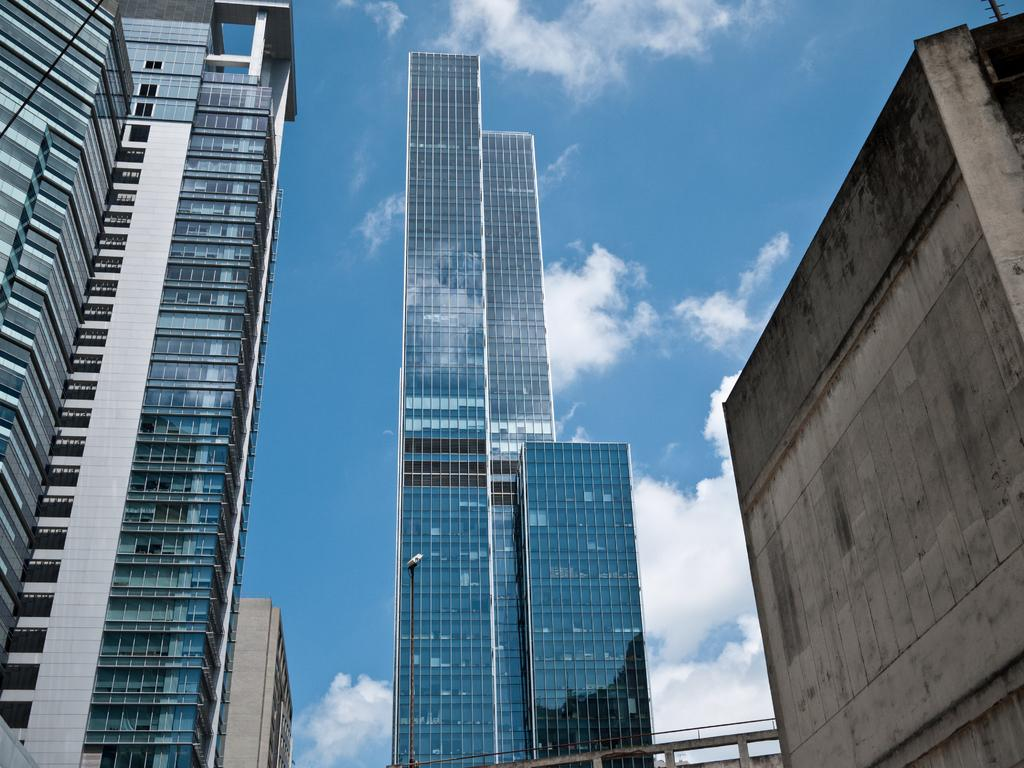What type of structures are located on either side of the image? There are huge buildings on either side of the image. What can be seen in the middle of the image? There is a big building with glass in the middle of the image. What is visible in the background of the image? The background of the image includes a blue sky. How does the goose contribute to the industry in the image? There is no goose present in the image, so it cannot contribute to any industry. 